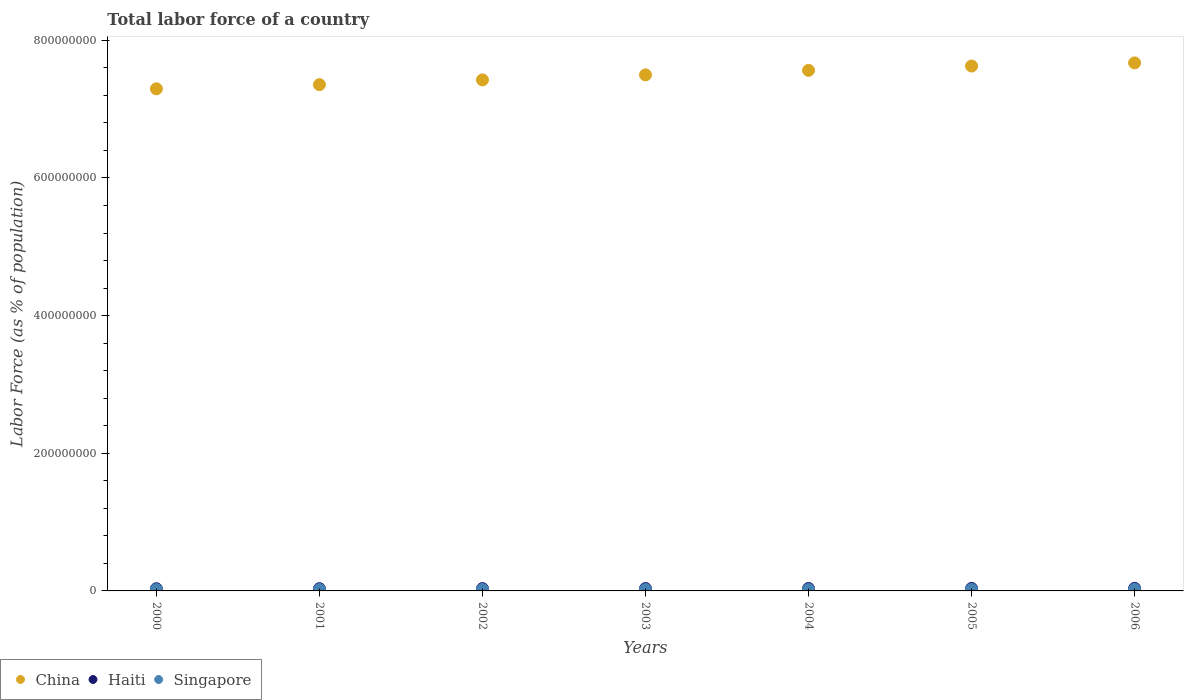How many different coloured dotlines are there?
Provide a succinct answer. 3. What is the percentage of labor force in Singapore in 2002?
Your response must be concise. 2.13e+06. Across all years, what is the maximum percentage of labor force in Singapore?
Ensure brevity in your answer.  2.36e+06. Across all years, what is the minimum percentage of labor force in China?
Your response must be concise. 7.29e+08. In which year was the percentage of labor force in Haiti maximum?
Keep it short and to the point. 2006. In which year was the percentage of labor force in China minimum?
Give a very brief answer. 2000. What is the total percentage of labor force in Singapore in the graph?
Keep it short and to the point. 1.52e+07. What is the difference between the percentage of labor force in Haiti in 2002 and that in 2003?
Offer a terse response. -9.76e+04. What is the difference between the percentage of labor force in China in 2004 and the percentage of labor force in Haiti in 2000?
Your response must be concise. 7.53e+08. What is the average percentage of labor force in Haiti per year?
Provide a succinct answer. 3.47e+06. In the year 2004, what is the difference between the percentage of labor force in China and percentage of labor force in Haiti?
Make the answer very short. 7.53e+08. What is the ratio of the percentage of labor force in Haiti in 2000 to that in 2003?
Give a very brief answer. 0.92. Is the percentage of labor force in Singapore in 2001 less than that in 2002?
Your answer should be very brief. Yes. Is the difference between the percentage of labor force in China in 2001 and 2006 greater than the difference between the percentage of labor force in Haiti in 2001 and 2006?
Offer a terse response. No. What is the difference between the highest and the second highest percentage of labor force in Singapore?
Provide a succinct answer. 1.19e+05. What is the difference between the highest and the lowest percentage of labor force in China?
Make the answer very short. 3.76e+07. Is the sum of the percentage of labor force in Haiti in 2001 and 2005 greater than the maximum percentage of labor force in China across all years?
Provide a succinct answer. No. Is it the case that in every year, the sum of the percentage of labor force in China and percentage of labor force in Singapore  is greater than the percentage of labor force in Haiti?
Offer a terse response. Yes. Is the percentage of labor force in Haiti strictly greater than the percentage of labor force in China over the years?
Offer a very short reply. No. Is the percentage of labor force in China strictly less than the percentage of labor force in Singapore over the years?
Provide a short and direct response. No. How many dotlines are there?
Keep it short and to the point. 3. How many years are there in the graph?
Make the answer very short. 7. How many legend labels are there?
Make the answer very short. 3. How are the legend labels stacked?
Your answer should be very brief. Horizontal. What is the title of the graph?
Keep it short and to the point. Total labor force of a country. Does "Sri Lanka" appear as one of the legend labels in the graph?
Your answer should be very brief. No. What is the label or title of the X-axis?
Offer a terse response. Years. What is the label or title of the Y-axis?
Offer a very short reply. Labor Force (as % of population). What is the Labor Force (as % of population) in China in 2000?
Keep it short and to the point. 7.29e+08. What is the Labor Force (as % of population) in Haiti in 2000?
Your answer should be very brief. 3.20e+06. What is the Labor Force (as % of population) in Singapore in 2000?
Offer a very short reply. 2.07e+06. What is the Labor Force (as % of population) of China in 2001?
Your answer should be very brief. 7.36e+08. What is the Labor Force (as % of population) of Haiti in 2001?
Give a very brief answer. 3.29e+06. What is the Labor Force (as % of population) of Singapore in 2001?
Provide a short and direct response. 2.12e+06. What is the Labor Force (as % of population) of China in 2002?
Your response must be concise. 7.42e+08. What is the Labor Force (as % of population) in Haiti in 2002?
Provide a succinct answer. 3.37e+06. What is the Labor Force (as % of population) in Singapore in 2002?
Your answer should be compact. 2.13e+06. What is the Labor Force (as % of population) of China in 2003?
Ensure brevity in your answer.  7.50e+08. What is the Labor Force (as % of population) in Haiti in 2003?
Make the answer very short. 3.47e+06. What is the Labor Force (as % of population) in Singapore in 2003?
Keep it short and to the point. 2.11e+06. What is the Labor Force (as % of population) of China in 2004?
Make the answer very short. 7.56e+08. What is the Labor Force (as % of population) in Haiti in 2004?
Provide a succinct answer. 3.56e+06. What is the Labor Force (as % of population) of Singapore in 2004?
Offer a terse response. 2.14e+06. What is the Labor Force (as % of population) in China in 2005?
Give a very brief answer. 7.63e+08. What is the Labor Force (as % of population) of Haiti in 2005?
Keep it short and to the point. 3.66e+06. What is the Labor Force (as % of population) in Singapore in 2005?
Give a very brief answer. 2.24e+06. What is the Labor Force (as % of population) of China in 2006?
Offer a terse response. 7.67e+08. What is the Labor Force (as % of population) of Haiti in 2006?
Keep it short and to the point. 3.76e+06. What is the Labor Force (as % of population) of Singapore in 2006?
Make the answer very short. 2.36e+06. Across all years, what is the maximum Labor Force (as % of population) in China?
Ensure brevity in your answer.  7.67e+08. Across all years, what is the maximum Labor Force (as % of population) of Haiti?
Make the answer very short. 3.76e+06. Across all years, what is the maximum Labor Force (as % of population) of Singapore?
Ensure brevity in your answer.  2.36e+06. Across all years, what is the minimum Labor Force (as % of population) of China?
Provide a succinct answer. 7.29e+08. Across all years, what is the minimum Labor Force (as % of population) of Haiti?
Your response must be concise. 3.20e+06. Across all years, what is the minimum Labor Force (as % of population) in Singapore?
Provide a short and direct response. 2.07e+06. What is the total Labor Force (as % of population) in China in the graph?
Give a very brief answer. 5.24e+09. What is the total Labor Force (as % of population) of Haiti in the graph?
Make the answer very short. 2.43e+07. What is the total Labor Force (as % of population) in Singapore in the graph?
Provide a succinct answer. 1.52e+07. What is the difference between the Labor Force (as % of population) of China in 2000 and that in 2001?
Keep it short and to the point. -6.05e+06. What is the difference between the Labor Force (as % of population) in Haiti in 2000 and that in 2001?
Make the answer very short. -8.40e+04. What is the difference between the Labor Force (as % of population) in Singapore in 2000 and that in 2001?
Your answer should be very brief. -5.27e+04. What is the difference between the Labor Force (as % of population) of China in 2000 and that in 2002?
Keep it short and to the point. -1.30e+07. What is the difference between the Labor Force (as % of population) of Haiti in 2000 and that in 2002?
Keep it short and to the point. -1.70e+05. What is the difference between the Labor Force (as % of population) of Singapore in 2000 and that in 2002?
Your response must be concise. -5.63e+04. What is the difference between the Labor Force (as % of population) of China in 2000 and that in 2003?
Your answer should be very brief. -2.03e+07. What is the difference between the Labor Force (as % of population) in Haiti in 2000 and that in 2003?
Make the answer very short. -2.67e+05. What is the difference between the Labor Force (as % of population) of Singapore in 2000 and that in 2003?
Make the answer very short. -3.64e+04. What is the difference between the Labor Force (as % of population) in China in 2000 and that in 2004?
Your answer should be very brief. -2.68e+07. What is the difference between the Labor Force (as % of population) of Haiti in 2000 and that in 2004?
Provide a succinct answer. -3.60e+05. What is the difference between the Labor Force (as % of population) of Singapore in 2000 and that in 2004?
Ensure brevity in your answer.  -7.34e+04. What is the difference between the Labor Force (as % of population) of China in 2000 and that in 2005?
Provide a short and direct response. -3.31e+07. What is the difference between the Labor Force (as % of population) of Haiti in 2000 and that in 2005?
Offer a terse response. -4.61e+05. What is the difference between the Labor Force (as % of population) of Singapore in 2000 and that in 2005?
Your answer should be compact. -1.69e+05. What is the difference between the Labor Force (as % of population) in China in 2000 and that in 2006?
Give a very brief answer. -3.76e+07. What is the difference between the Labor Force (as % of population) of Haiti in 2000 and that in 2006?
Ensure brevity in your answer.  -5.57e+05. What is the difference between the Labor Force (as % of population) in Singapore in 2000 and that in 2006?
Your answer should be compact. -2.88e+05. What is the difference between the Labor Force (as % of population) of China in 2001 and that in 2002?
Offer a very short reply. -6.92e+06. What is the difference between the Labor Force (as % of population) of Haiti in 2001 and that in 2002?
Offer a terse response. -8.55e+04. What is the difference between the Labor Force (as % of population) in Singapore in 2001 and that in 2002?
Ensure brevity in your answer.  -3507. What is the difference between the Labor Force (as % of population) in China in 2001 and that in 2003?
Offer a very short reply. -1.42e+07. What is the difference between the Labor Force (as % of population) in Haiti in 2001 and that in 2003?
Provide a short and direct response. -1.83e+05. What is the difference between the Labor Force (as % of population) of Singapore in 2001 and that in 2003?
Ensure brevity in your answer.  1.63e+04. What is the difference between the Labor Force (as % of population) in China in 2001 and that in 2004?
Ensure brevity in your answer.  -2.08e+07. What is the difference between the Labor Force (as % of population) of Haiti in 2001 and that in 2004?
Make the answer very short. -2.76e+05. What is the difference between the Labor Force (as % of population) of Singapore in 2001 and that in 2004?
Ensure brevity in your answer.  -2.07e+04. What is the difference between the Labor Force (as % of population) in China in 2001 and that in 2005?
Provide a succinct answer. -2.71e+07. What is the difference between the Labor Force (as % of population) of Haiti in 2001 and that in 2005?
Offer a very short reply. -3.77e+05. What is the difference between the Labor Force (as % of population) of Singapore in 2001 and that in 2005?
Your answer should be very brief. -1.17e+05. What is the difference between the Labor Force (as % of population) of China in 2001 and that in 2006?
Offer a terse response. -3.16e+07. What is the difference between the Labor Force (as % of population) of Haiti in 2001 and that in 2006?
Your answer should be very brief. -4.73e+05. What is the difference between the Labor Force (as % of population) in Singapore in 2001 and that in 2006?
Provide a succinct answer. -2.36e+05. What is the difference between the Labor Force (as % of population) in China in 2002 and that in 2003?
Your response must be concise. -7.28e+06. What is the difference between the Labor Force (as % of population) in Haiti in 2002 and that in 2003?
Offer a very short reply. -9.76e+04. What is the difference between the Labor Force (as % of population) in Singapore in 2002 and that in 2003?
Provide a short and direct response. 1.98e+04. What is the difference between the Labor Force (as % of population) of China in 2002 and that in 2004?
Your answer should be very brief. -1.38e+07. What is the difference between the Labor Force (as % of population) in Haiti in 2002 and that in 2004?
Your answer should be very brief. -1.91e+05. What is the difference between the Labor Force (as % of population) of Singapore in 2002 and that in 2004?
Your response must be concise. -1.71e+04. What is the difference between the Labor Force (as % of population) in China in 2002 and that in 2005?
Keep it short and to the point. -2.02e+07. What is the difference between the Labor Force (as % of population) of Haiti in 2002 and that in 2005?
Give a very brief answer. -2.91e+05. What is the difference between the Labor Force (as % of population) of Singapore in 2002 and that in 2005?
Provide a short and direct response. -1.13e+05. What is the difference between the Labor Force (as % of population) of China in 2002 and that in 2006?
Your answer should be compact. -2.47e+07. What is the difference between the Labor Force (as % of population) in Haiti in 2002 and that in 2006?
Your response must be concise. -3.88e+05. What is the difference between the Labor Force (as % of population) in Singapore in 2002 and that in 2006?
Your response must be concise. -2.32e+05. What is the difference between the Labor Force (as % of population) in China in 2003 and that in 2004?
Offer a terse response. -6.56e+06. What is the difference between the Labor Force (as % of population) in Haiti in 2003 and that in 2004?
Offer a very short reply. -9.34e+04. What is the difference between the Labor Force (as % of population) of Singapore in 2003 and that in 2004?
Your answer should be very brief. -3.70e+04. What is the difference between the Labor Force (as % of population) of China in 2003 and that in 2005?
Ensure brevity in your answer.  -1.29e+07. What is the difference between the Labor Force (as % of population) in Haiti in 2003 and that in 2005?
Provide a succinct answer. -1.94e+05. What is the difference between the Labor Force (as % of population) of Singapore in 2003 and that in 2005?
Keep it short and to the point. -1.33e+05. What is the difference between the Labor Force (as % of population) of China in 2003 and that in 2006?
Keep it short and to the point. -1.74e+07. What is the difference between the Labor Force (as % of population) in Haiti in 2003 and that in 2006?
Your answer should be compact. -2.90e+05. What is the difference between the Labor Force (as % of population) of Singapore in 2003 and that in 2006?
Provide a short and direct response. -2.52e+05. What is the difference between the Labor Force (as % of population) of China in 2004 and that in 2005?
Make the answer very short. -6.30e+06. What is the difference between the Labor Force (as % of population) in Haiti in 2004 and that in 2005?
Provide a short and direct response. -1.00e+05. What is the difference between the Labor Force (as % of population) in Singapore in 2004 and that in 2005?
Offer a very short reply. -9.61e+04. What is the difference between the Labor Force (as % of population) in China in 2004 and that in 2006?
Provide a short and direct response. -1.08e+07. What is the difference between the Labor Force (as % of population) of Haiti in 2004 and that in 2006?
Keep it short and to the point. -1.97e+05. What is the difference between the Labor Force (as % of population) of Singapore in 2004 and that in 2006?
Provide a short and direct response. -2.15e+05. What is the difference between the Labor Force (as % of population) of China in 2005 and that in 2006?
Keep it short and to the point. -4.53e+06. What is the difference between the Labor Force (as % of population) of Haiti in 2005 and that in 2006?
Your answer should be very brief. -9.67e+04. What is the difference between the Labor Force (as % of population) in Singapore in 2005 and that in 2006?
Your response must be concise. -1.19e+05. What is the difference between the Labor Force (as % of population) of China in 2000 and the Labor Force (as % of population) of Haiti in 2001?
Offer a very short reply. 7.26e+08. What is the difference between the Labor Force (as % of population) of China in 2000 and the Labor Force (as % of population) of Singapore in 2001?
Provide a short and direct response. 7.27e+08. What is the difference between the Labor Force (as % of population) in Haiti in 2000 and the Labor Force (as % of population) in Singapore in 2001?
Provide a succinct answer. 1.08e+06. What is the difference between the Labor Force (as % of population) in China in 2000 and the Labor Force (as % of population) in Haiti in 2002?
Provide a short and direct response. 7.26e+08. What is the difference between the Labor Force (as % of population) in China in 2000 and the Labor Force (as % of population) in Singapore in 2002?
Provide a succinct answer. 7.27e+08. What is the difference between the Labor Force (as % of population) in Haiti in 2000 and the Labor Force (as % of population) in Singapore in 2002?
Make the answer very short. 1.08e+06. What is the difference between the Labor Force (as % of population) in China in 2000 and the Labor Force (as % of population) in Haiti in 2003?
Provide a short and direct response. 7.26e+08. What is the difference between the Labor Force (as % of population) of China in 2000 and the Labor Force (as % of population) of Singapore in 2003?
Keep it short and to the point. 7.27e+08. What is the difference between the Labor Force (as % of population) of Haiti in 2000 and the Labor Force (as % of population) of Singapore in 2003?
Ensure brevity in your answer.  1.10e+06. What is the difference between the Labor Force (as % of population) of China in 2000 and the Labor Force (as % of population) of Haiti in 2004?
Make the answer very short. 7.26e+08. What is the difference between the Labor Force (as % of population) in China in 2000 and the Labor Force (as % of population) in Singapore in 2004?
Your response must be concise. 7.27e+08. What is the difference between the Labor Force (as % of population) in Haiti in 2000 and the Labor Force (as % of population) in Singapore in 2004?
Ensure brevity in your answer.  1.06e+06. What is the difference between the Labor Force (as % of population) of China in 2000 and the Labor Force (as % of population) of Haiti in 2005?
Offer a terse response. 7.26e+08. What is the difference between the Labor Force (as % of population) of China in 2000 and the Labor Force (as % of population) of Singapore in 2005?
Provide a succinct answer. 7.27e+08. What is the difference between the Labor Force (as % of population) of Haiti in 2000 and the Labor Force (as % of population) of Singapore in 2005?
Your answer should be compact. 9.65e+05. What is the difference between the Labor Force (as % of population) in China in 2000 and the Labor Force (as % of population) in Haiti in 2006?
Offer a terse response. 7.26e+08. What is the difference between the Labor Force (as % of population) of China in 2000 and the Labor Force (as % of population) of Singapore in 2006?
Keep it short and to the point. 7.27e+08. What is the difference between the Labor Force (as % of population) in Haiti in 2000 and the Labor Force (as % of population) in Singapore in 2006?
Give a very brief answer. 8.46e+05. What is the difference between the Labor Force (as % of population) of China in 2001 and the Labor Force (as % of population) of Haiti in 2002?
Your answer should be very brief. 7.32e+08. What is the difference between the Labor Force (as % of population) of China in 2001 and the Labor Force (as % of population) of Singapore in 2002?
Your answer should be very brief. 7.33e+08. What is the difference between the Labor Force (as % of population) of Haiti in 2001 and the Labor Force (as % of population) of Singapore in 2002?
Your response must be concise. 1.16e+06. What is the difference between the Labor Force (as % of population) in China in 2001 and the Labor Force (as % of population) in Haiti in 2003?
Your answer should be compact. 7.32e+08. What is the difference between the Labor Force (as % of population) of China in 2001 and the Labor Force (as % of population) of Singapore in 2003?
Ensure brevity in your answer.  7.33e+08. What is the difference between the Labor Force (as % of population) in Haiti in 2001 and the Labor Force (as % of population) in Singapore in 2003?
Give a very brief answer. 1.18e+06. What is the difference between the Labor Force (as % of population) in China in 2001 and the Labor Force (as % of population) in Haiti in 2004?
Your answer should be very brief. 7.32e+08. What is the difference between the Labor Force (as % of population) of China in 2001 and the Labor Force (as % of population) of Singapore in 2004?
Give a very brief answer. 7.33e+08. What is the difference between the Labor Force (as % of population) in Haiti in 2001 and the Labor Force (as % of population) in Singapore in 2004?
Provide a short and direct response. 1.15e+06. What is the difference between the Labor Force (as % of population) of China in 2001 and the Labor Force (as % of population) of Haiti in 2005?
Provide a succinct answer. 7.32e+08. What is the difference between the Labor Force (as % of population) in China in 2001 and the Labor Force (as % of population) in Singapore in 2005?
Give a very brief answer. 7.33e+08. What is the difference between the Labor Force (as % of population) in Haiti in 2001 and the Labor Force (as % of population) in Singapore in 2005?
Offer a very short reply. 1.05e+06. What is the difference between the Labor Force (as % of population) in China in 2001 and the Labor Force (as % of population) in Haiti in 2006?
Keep it short and to the point. 7.32e+08. What is the difference between the Labor Force (as % of population) of China in 2001 and the Labor Force (as % of population) of Singapore in 2006?
Keep it short and to the point. 7.33e+08. What is the difference between the Labor Force (as % of population) of Haiti in 2001 and the Labor Force (as % of population) of Singapore in 2006?
Offer a terse response. 9.30e+05. What is the difference between the Labor Force (as % of population) of China in 2002 and the Labor Force (as % of population) of Haiti in 2003?
Offer a very short reply. 7.39e+08. What is the difference between the Labor Force (as % of population) in China in 2002 and the Labor Force (as % of population) in Singapore in 2003?
Make the answer very short. 7.40e+08. What is the difference between the Labor Force (as % of population) of Haiti in 2002 and the Labor Force (as % of population) of Singapore in 2003?
Offer a very short reply. 1.27e+06. What is the difference between the Labor Force (as % of population) of China in 2002 and the Labor Force (as % of population) of Haiti in 2004?
Keep it short and to the point. 7.39e+08. What is the difference between the Labor Force (as % of population) in China in 2002 and the Labor Force (as % of population) in Singapore in 2004?
Ensure brevity in your answer.  7.40e+08. What is the difference between the Labor Force (as % of population) in Haiti in 2002 and the Labor Force (as % of population) in Singapore in 2004?
Provide a short and direct response. 1.23e+06. What is the difference between the Labor Force (as % of population) of China in 2002 and the Labor Force (as % of population) of Haiti in 2005?
Keep it short and to the point. 7.39e+08. What is the difference between the Labor Force (as % of population) of China in 2002 and the Labor Force (as % of population) of Singapore in 2005?
Your answer should be very brief. 7.40e+08. What is the difference between the Labor Force (as % of population) in Haiti in 2002 and the Labor Force (as % of population) in Singapore in 2005?
Ensure brevity in your answer.  1.13e+06. What is the difference between the Labor Force (as % of population) in China in 2002 and the Labor Force (as % of population) in Haiti in 2006?
Offer a very short reply. 7.39e+08. What is the difference between the Labor Force (as % of population) of China in 2002 and the Labor Force (as % of population) of Singapore in 2006?
Provide a succinct answer. 7.40e+08. What is the difference between the Labor Force (as % of population) in Haiti in 2002 and the Labor Force (as % of population) in Singapore in 2006?
Your answer should be compact. 1.02e+06. What is the difference between the Labor Force (as % of population) of China in 2003 and the Labor Force (as % of population) of Haiti in 2004?
Give a very brief answer. 7.46e+08. What is the difference between the Labor Force (as % of population) of China in 2003 and the Labor Force (as % of population) of Singapore in 2004?
Offer a very short reply. 7.48e+08. What is the difference between the Labor Force (as % of population) of Haiti in 2003 and the Labor Force (as % of population) of Singapore in 2004?
Your response must be concise. 1.33e+06. What is the difference between the Labor Force (as % of population) of China in 2003 and the Labor Force (as % of population) of Haiti in 2005?
Offer a very short reply. 7.46e+08. What is the difference between the Labor Force (as % of population) in China in 2003 and the Labor Force (as % of population) in Singapore in 2005?
Offer a very short reply. 7.48e+08. What is the difference between the Labor Force (as % of population) in Haiti in 2003 and the Labor Force (as % of population) in Singapore in 2005?
Provide a succinct answer. 1.23e+06. What is the difference between the Labor Force (as % of population) of China in 2003 and the Labor Force (as % of population) of Haiti in 2006?
Offer a very short reply. 7.46e+08. What is the difference between the Labor Force (as % of population) of China in 2003 and the Labor Force (as % of population) of Singapore in 2006?
Your response must be concise. 7.47e+08. What is the difference between the Labor Force (as % of population) in Haiti in 2003 and the Labor Force (as % of population) in Singapore in 2006?
Keep it short and to the point. 1.11e+06. What is the difference between the Labor Force (as % of population) of China in 2004 and the Labor Force (as % of population) of Haiti in 2005?
Ensure brevity in your answer.  7.53e+08. What is the difference between the Labor Force (as % of population) in China in 2004 and the Labor Force (as % of population) in Singapore in 2005?
Provide a short and direct response. 7.54e+08. What is the difference between the Labor Force (as % of population) of Haiti in 2004 and the Labor Force (as % of population) of Singapore in 2005?
Offer a terse response. 1.33e+06. What is the difference between the Labor Force (as % of population) in China in 2004 and the Labor Force (as % of population) in Haiti in 2006?
Keep it short and to the point. 7.53e+08. What is the difference between the Labor Force (as % of population) of China in 2004 and the Labor Force (as % of population) of Singapore in 2006?
Provide a succinct answer. 7.54e+08. What is the difference between the Labor Force (as % of population) of Haiti in 2004 and the Labor Force (as % of population) of Singapore in 2006?
Make the answer very short. 1.21e+06. What is the difference between the Labor Force (as % of population) in China in 2005 and the Labor Force (as % of population) in Haiti in 2006?
Offer a very short reply. 7.59e+08. What is the difference between the Labor Force (as % of population) of China in 2005 and the Labor Force (as % of population) of Singapore in 2006?
Give a very brief answer. 7.60e+08. What is the difference between the Labor Force (as % of population) in Haiti in 2005 and the Labor Force (as % of population) in Singapore in 2006?
Your response must be concise. 1.31e+06. What is the average Labor Force (as % of population) of China per year?
Keep it short and to the point. 7.49e+08. What is the average Labor Force (as % of population) of Haiti per year?
Provide a short and direct response. 3.47e+06. What is the average Labor Force (as % of population) of Singapore per year?
Ensure brevity in your answer.  2.17e+06. In the year 2000, what is the difference between the Labor Force (as % of population) in China and Labor Force (as % of population) in Haiti?
Ensure brevity in your answer.  7.26e+08. In the year 2000, what is the difference between the Labor Force (as % of population) in China and Labor Force (as % of population) in Singapore?
Your response must be concise. 7.27e+08. In the year 2000, what is the difference between the Labor Force (as % of population) of Haiti and Labor Force (as % of population) of Singapore?
Provide a succinct answer. 1.13e+06. In the year 2001, what is the difference between the Labor Force (as % of population) in China and Labor Force (as % of population) in Haiti?
Give a very brief answer. 7.32e+08. In the year 2001, what is the difference between the Labor Force (as % of population) in China and Labor Force (as % of population) in Singapore?
Ensure brevity in your answer.  7.33e+08. In the year 2001, what is the difference between the Labor Force (as % of population) of Haiti and Labor Force (as % of population) of Singapore?
Provide a succinct answer. 1.17e+06. In the year 2002, what is the difference between the Labor Force (as % of population) of China and Labor Force (as % of population) of Haiti?
Give a very brief answer. 7.39e+08. In the year 2002, what is the difference between the Labor Force (as % of population) in China and Labor Force (as % of population) in Singapore?
Your answer should be very brief. 7.40e+08. In the year 2002, what is the difference between the Labor Force (as % of population) of Haiti and Labor Force (as % of population) of Singapore?
Keep it short and to the point. 1.25e+06. In the year 2003, what is the difference between the Labor Force (as % of population) of China and Labor Force (as % of population) of Haiti?
Make the answer very short. 7.46e+08. In the year 2003, what is the difference between the Labor Force (as % of population) of China and Labor Force (as % of population) of Singapore?
Your answer should be compact. 7.48e+08. In the year 2003, what is the difference between the Labor Force (as % of population) in Haiti and Labor Force (as % of population) in Singapore?
Your response must be concise. 1.37e+06. In the year 2004, what is the difference between the Labor Force (as % of population) in China and Labor Force (as % of population) in Haiti?
Make the answer very short. 7.53e+08. In the year 2004, what is the difference between the Labor Force (as % of population) in China and Labor Force (as % of population) in Singapore?
Offer a terse response. 7.54e+08. In the year 2004, what is the difference between the Labor Force (as % of population) in Haiti and Labor Force (as % of population) in Singapore?
Keep it short and to the point. 1.42e+06. In the year 2005, what is the difference between the Labor Force (as % of population) in China and Labor Force (as % of population) in Haiti?
Ensure brevity in your answer.  7.59e+08. In the year 2005, what is the difference between the Labor Force (as % of population) of China and Labor Force (as % of population) of Singapore?
Give a very brief answer. 7.60e+08. In the year 2005, what is the difference between the Labor Force (as % of population) in Haiti and Labor Force (as % of population) in Singapore?
Offer a terse response. 1.43e+06. In the year 2006, what is the difference between the Labor Force (as % of population) of China and Labor Force (as % of population) of Haiti?
Make the answer very short. 7.63e+08. In the year 2006, what is the difference between the Labor Force (as % of population) in China and Labor Force (as % of population) in Singapore?
Make the answer very short. 7.65e+08. In the year 2006, what is the difference between the Labor Force (as % of population) in Haiti and Labor Force (as % of population) in Singapore?
Provide a short and direct response. 1.40e+06. What is the ratio of the Labor Force (as % of population) in Haiti in 2000 to that in 2001?
Provide a succinct answer. 0.97. What is the ratio of the Labor Force (as % of population) in Singapore in 2000 to that in 2001?
Make the answer very short. 0.98. What is the ratio of the Labor Force (as % of population) in China in 2000 to that in 2002?
Provide a succinct answer. 0.98. What is the ratio of the Labor Force (as % of population) in Haiti in 2000 to that in 2002?
Your answer should be very brief. 0.95. What is the ratio of the Labor Force (as % of population) of Singapore in 2000 to that in 2002?
Offer a terse response. 0.97. What is the ratio of the Labor Force (as % of population) in Haiti in 2000 to that in 2003?
Ensure brevity in your answer.  0.92. What is the ratio of the Labor Force (as % of population) in Singapore in 2000 to that in 2003?
Ensure brevity in your answer.  0.98. What is the ratio of the Labor Force (as % of population) of China in 2000 to that in 2004?
Make the answer very short. 0.96. What is the ratio of the Labor Force (as % of population) in Haiti in 2000 to that in 2004?
Provide a succinct answer. 0.9. What is the ratio of the Labor Force (as % of population) in Singapore in 2000 to that in 2004?
Offer a very short reply. 0.97. What is the ratio of the Labor Force (as % of population) of China in 2000 to that in 2005?
Make the answer very short. 0.96. What is the ratio of the Labor Force (as % of population) in Haiti in 2000 to that in 2005?
Your answer should be compact. 0.87. What is the ratio of the Labor Force (as % of population) of Singapore in 2000 to that in 2005?
Ensure brevity in your answer.  0.92. What is the ratio of the Labor Force (as % of population) of China in 2000 to that in 2006?
Your response must be concise. 0.95. What is the ratio of the Labor Force (as % of population) of Haiti in 2000 to that in 2006?
Offer a very short reply. 0.85. What is the ratio of the Labor Force (as % of population) in Singapore in 2000 to that in 2006?
Your answer should be very brief. 0.88. What is the ratio of the Labor Force (as % of population) in Haiti in 2001 to that in 2002?
Your answer should be very brief. 0.97. What is the ratio of the Labor Force (as % of population) of Singapore in 2001 to that in 2002?
Your answer should be compact. 1. What is the ratio of the Labor Force (as % of population) in China in 2001 to that in 2003?
Offer a terse response. 0.98. What is the ratio of the Labor Force (as % of population) of Haiti in 2001 to that in 2003?
Give a very brief answer. 0.95. What is the ratio of the Labor Force (as % of population) of Singapore in 2001 to that in 2003?
Provide a succinct answer. 1.01. What is the ratio of the Labor Force (as % of population) in China in 2001 to that in 2004?
Your answer should be compact. 0.97. What is the ratio of the Labor Force (as % of population) in Haiti in 2001 to that in 2004?
Keep it short and to the point. 0.92. What is the ratio of the Labor Force (as % of population) in Singapore in 2001 to that in 2004?
Offer a terse response. 0.99. What is the ratio of the Labor Force (as % of population) of China in 2001 to that in 2005?
Make the answer very short. 0.96. What is the ratio of the Labor Force (as % of population) of Haiti in 2001 to that in 2005?
Offer a very short reply. 0.9. What is the ratio of the Labor Force (as % of population) in Singapore in 2001 to that in 2005?
Your response must be concise. 0.95. What is the ratio of the Labor Force (as % of population) in China in 2001 to that in 2006?
Give a very brief answer. 0.96. What is the ratio of the Labor Force (as % of population) of Haiti in 2001 to that in 2006?
Give a very brief answer. 0.87. What is the ratio of the Labor Force (as % of population) in China in 2002 to that in 2003?
Provide a succinct answer. 0.99. What is the ratio of the Labor Force (as % of population) of Haiti in 2002 to that in 2003?
Your answer should be compact. 0.97. What is the ratio of the Labor Force (as % of population) in Singapore in 2002 to that in 2003?
Offer a very short reply. 1.01. What is the ratio of the Labor Force (as % of population) in China in 2002 to that in 2004?
Ensure brevity in your answer.  0.98. What is the ratio of the Labor Force (as % of population) of Haiti in 2002 to that in 2004?
Ensure brevity in your answer.  0.95. What is the ratio of the Labor Force (as % of population) of Singapore in 2002 to that in 2004?
Your answer should be very brief. 0.99. What is the ratio of the Labor Force (as % of population) of China in 2002 to that in 2005?
Your answer should be very brief. 0.97. What is the ratio of the Labor Force (as % of population) in Haiti in 2002 to that in 2005?
Make the answer very short. 0.92. What is the ratio of the Labor Force (as % of population) in Singapore in 2002 to that in 2005?
Provide a succinct answer. 0.95. What is the ratio of the Labor Force (as % of population) of China in 2002 to that in 2006?
Provide a short and direct response. 0.97. What is the ratio of the Labor Force (as % of population) of Haiti in 2002 to that in 2006?
Ensure brevity in your answer.  0.9. What is the ratio of the Labor Force (as % of population) of Singapore in 2002 to that in 2006?
Your answer should be compact. 0.9. What is the ratio of the Labor Force (as % of population) in Haiti in 2003 to that in 2004?
Your answer should be very brief. 0.97. What is the ratio of the Labor Force (as % of population) of Singapore in 2003 to that in 2004?
Make the answer very short. 0.98. What is the ratio of the Labor Force (as % of population) of China in 2003 to that in 2005?
Your answer should be compact. 0.98. What is the ratio of the Labor Force (as % of population) in Haiti in 2003 to that in 2005?
Your response must be concise. 0.95. What is the ratio of the Labor Force (as % of population) in Singapore in 2003 to that in 2005?
Provide a short and direct response. 0.94. What is the ratio of the Labor Force (as % of population) of China in 2003 to that in 2006?
Ensure brevity in your answer.  0.98. What is the ratio of the Labor Force (as % of population) of Haiti in 2003 to that in 2006?
Keep it short and to the point. 0.92. What is the ratio of the Labor Force (as % of population) in Singapore in 2003 to that in 2006?
Ensure brevity in your answer.  0.89. What is the ratio of the Labor Force (as % of population) in Haiti in 2004 to that in 2005?
Make the answer very short. 0.97. What is the ratio of the Labor Force (as % of population) in Singapore in 2004 to that in 2005?
Offer a terse response. 0.96. What is the ratio of the Labor Force (as % of population) in China in 2004 to that in 2006?
Give a very brief answer. 0.99. What is the ratio of the Labor Force (as % of population) in Haiti in 2004 to that in 2006?
Give a very brief answer. 0.95. What is the ratio of the Labor Force (as % of population) in Singapore in 2004 to that in 2006?
Ensure brevity in your answer.  0.91. What is the ratio of the Labor Force (as % of population) of Haiti in 2005 to that in 2006?
Offer a very short reply. 0.97. What is the ratio of the Labor Force (as % of population) of Singapore in 2005 to that in 2006?
Your answer should be compact. 0.95. What is the difference between the highest and the second highest Labor Force (as % of population) of China?
Offer a terse response. 4.53e+06. What is the difference between the highest and the second highest Labor Force (as % of population) of Haiti?
Ensure brevity in your answer.  9.67e+04. What is the difference between the highest and the second highest Labor Force (as % of population) in Singapore?
Make the answer very short. 1.19e+05. What is the difference between the highest and the lowest Labor Force (as % of population) of China?
Your answer should be compact. 3.76e+07. What is the difference between the highest and the lowest Labor Force (as % of population) of Haiti?
Offer a very short reply. 5.57e+05. What is the difference between the highest and the lowest Labor Force (as % of population) in Singapore?
Provide a short and direct response. 2.88e+05. 